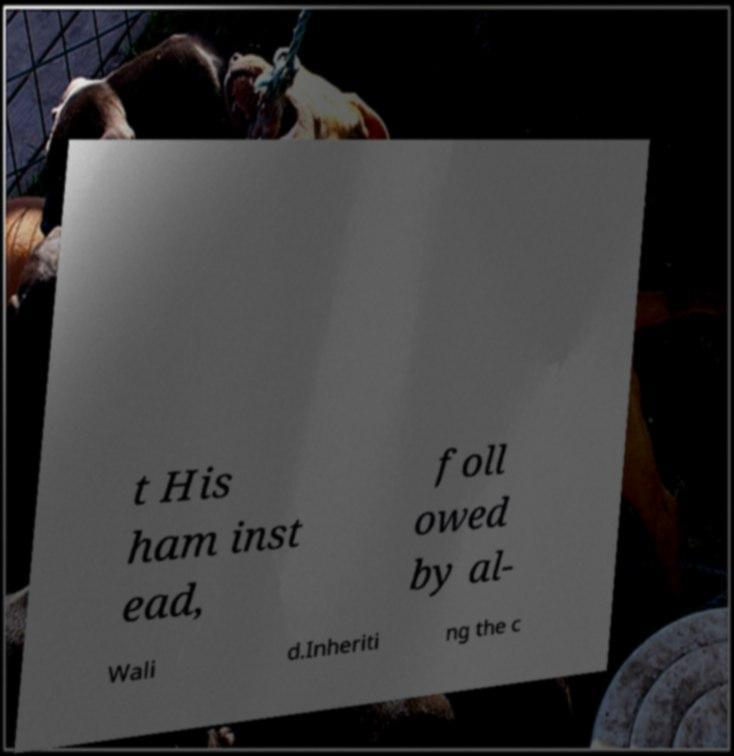Could you extract and type out the text from this image? t His ham inst ead, foll owed by al- Wali d.Inheriti ng the c 